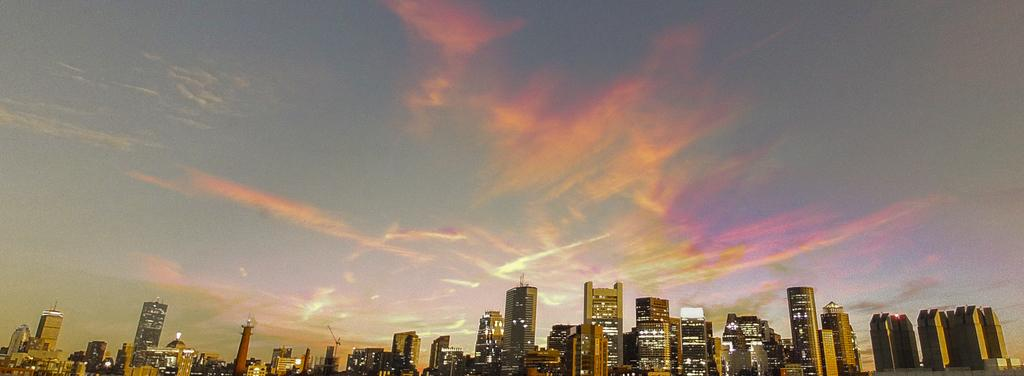What type of structures can be seen in the image? There are many buildings in the image. Are there any visible sources of light in the image? Yes, there are lights visible in the image. How would you describe the sky in the image? The sky appears to be cloudy and has pale orange and pale blue colors. How many jellyfish can be seen swimming in the sky in the image? There are no jellyfish present in the image, as it features buildings and a cloudy sky with pale orange and pale blue colors. 